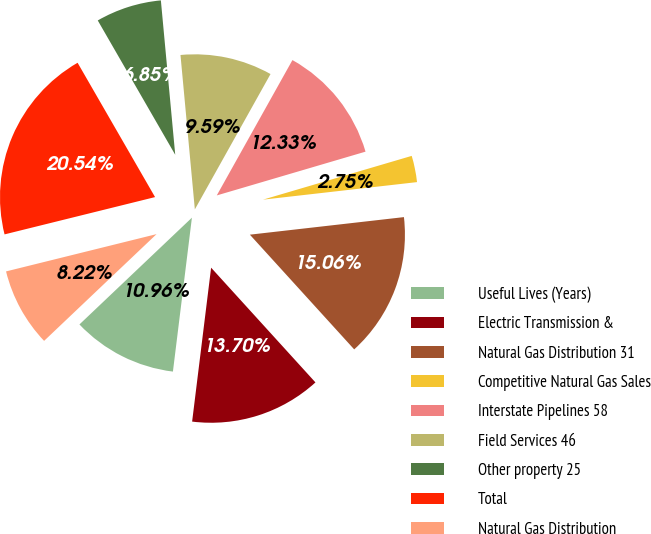<chart> <loc_0><loc_0><loc_500><loc_500><pie_chart><fcel>Useful Lives (Years)<fcel>Electric Transmission &<fcel>Natural Gas Distribution 31<fcel>Competitive Natural Gas Sales<fcel>Interstate Pipelines 58<fcel>Field Services 46<fcel>Other property 25<fcel>Total<fcel>Natural Gas Distribution<nl><fcel>10.96%<fcel>13.7%<fcel>15.06%<fcel>2.75%<fcel>12.33%<fcel>9.59%<fcel>6.85%<fcel>20.54%<fcel>8.22%<nl></chart> 